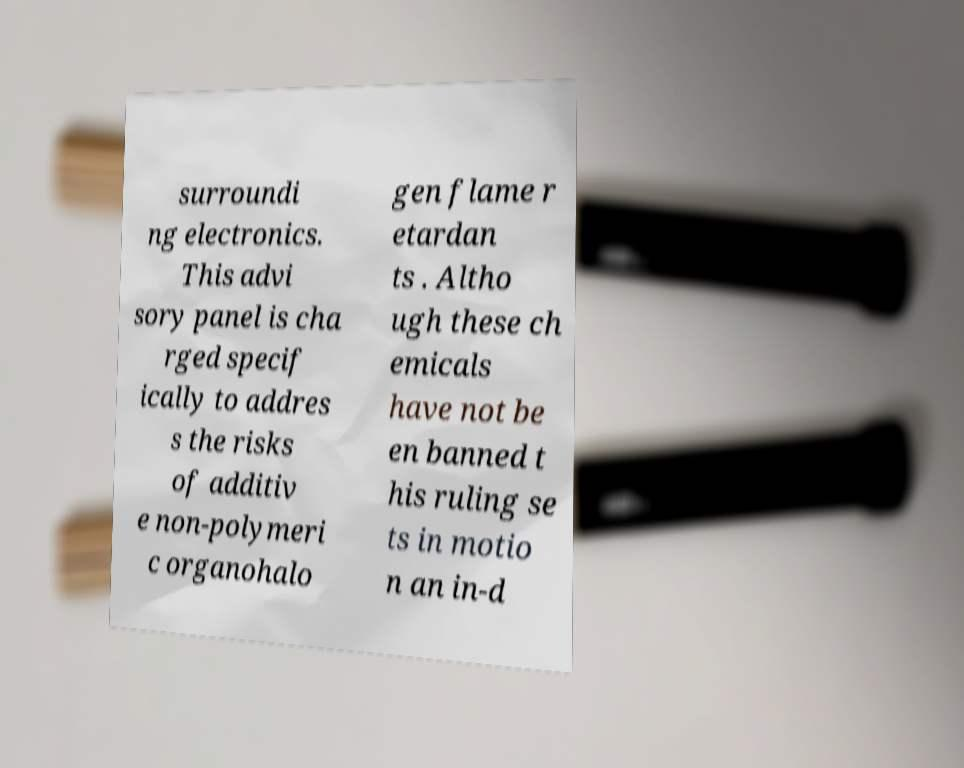Could you extract and type out the text from this image? surroundi ng electronics. This advi sory panel is cha rged specif ically to addres s the risks of additiv e non-polymeri c organohalo gen flame r etardan ts . Altho ugh these ch emicals have not be en banned t his ruling se ts in motio n an in-d 